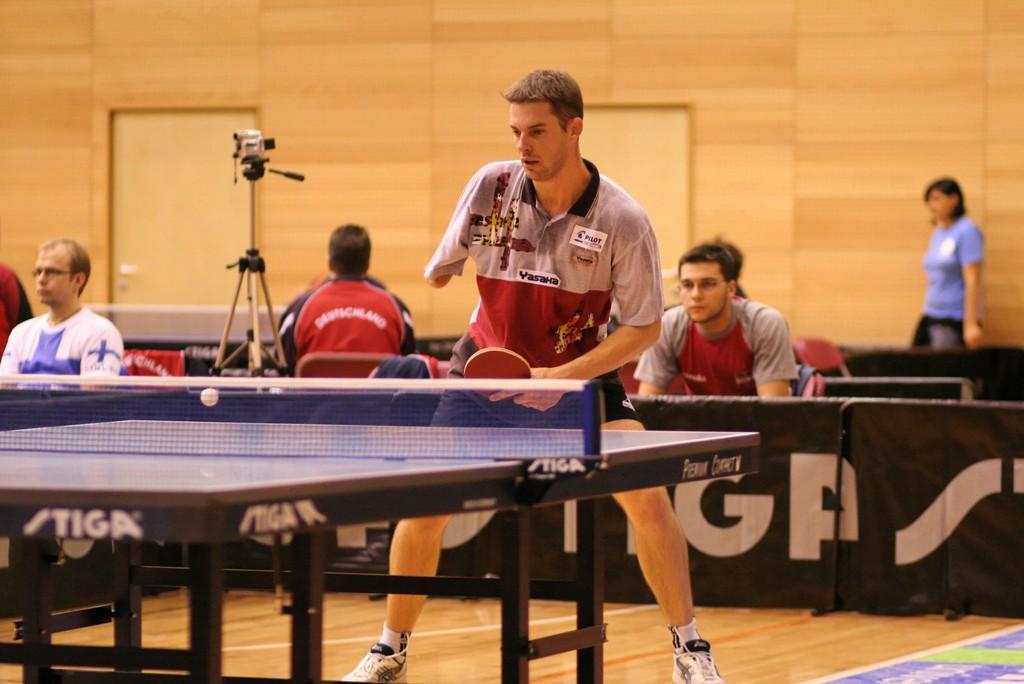Please provide a concise description of this image. This picture is of inside. In the center there is a man standing and playing table tennis and there is a table-tennis table. On the left corner there is a man wearing white color t-shirt and sitting on the chair, beside him we can see a camera attached to the stand and a person sitting on the chair. On the right we can see the person sitting on the chair and in the background there is a door, a wall and a woman wearing blue color t-shirt seems to be standing. 